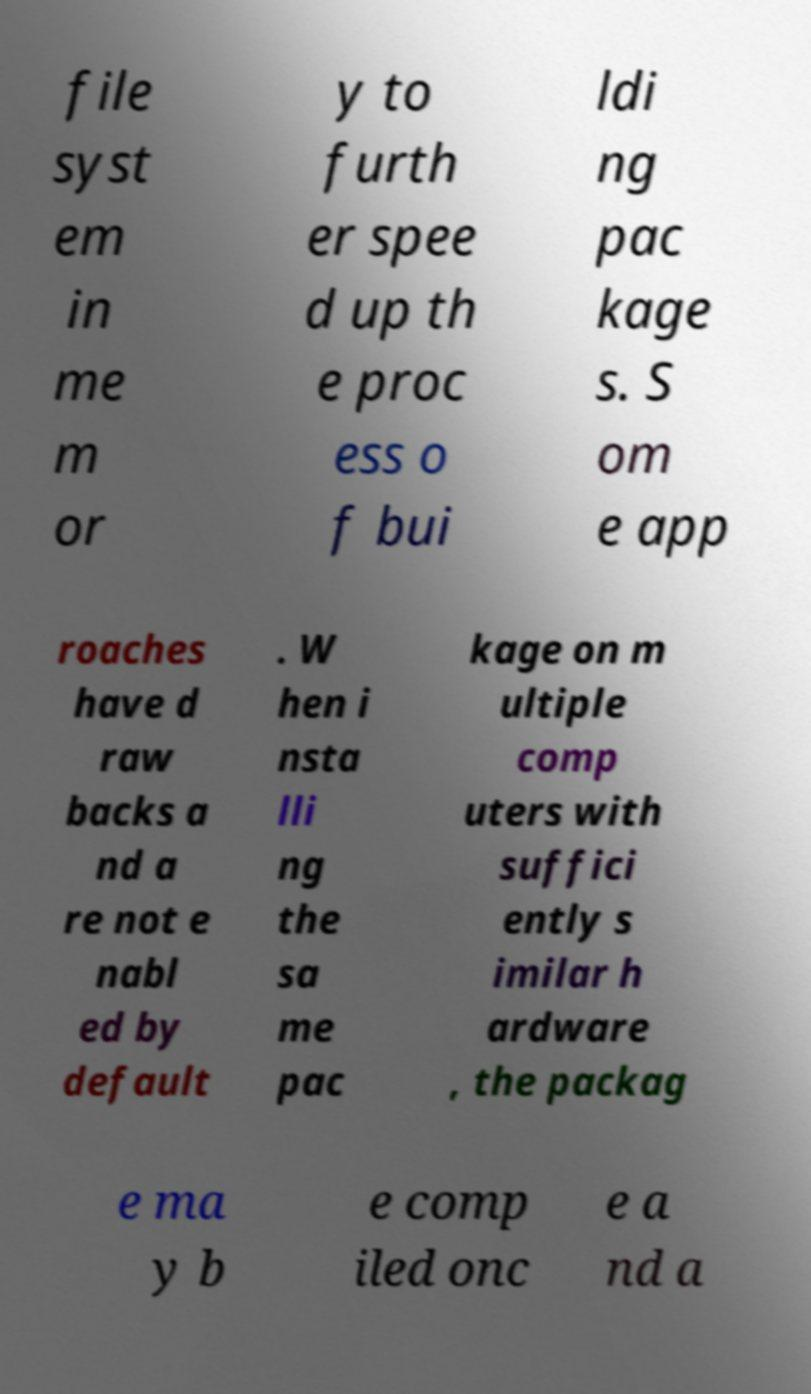Could you extract and type out the text from this image? file syst em in me m or y to furth er spee d up th e proc ess o f bui ldi ng pac kage s. S om e app roaches have d raw backs a nd a re not e nabl ed by default . W hen i nsta lli ng the sa me pac kage on m ultiple comp uters with suffici ently s imilar h ardware , the packag e ma y b e comp iled onc e a nd a 